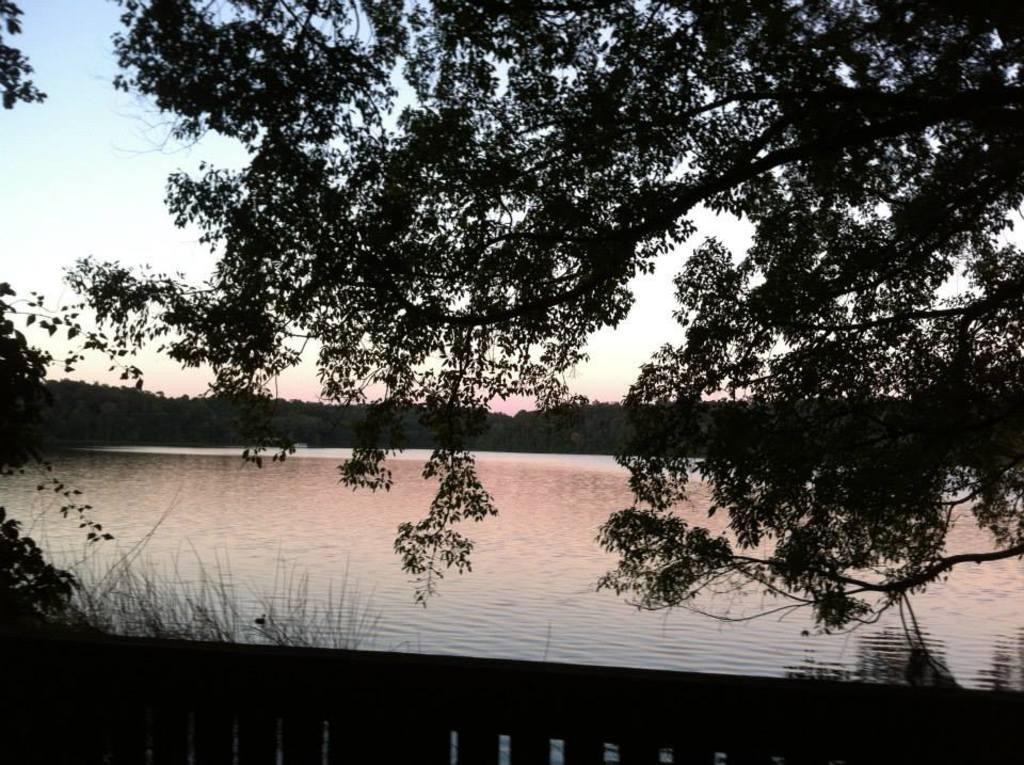How would you summarize this image in a sentence or two? In this image we can see some trees, grass, fencing, also we can see the river, and the sky. 